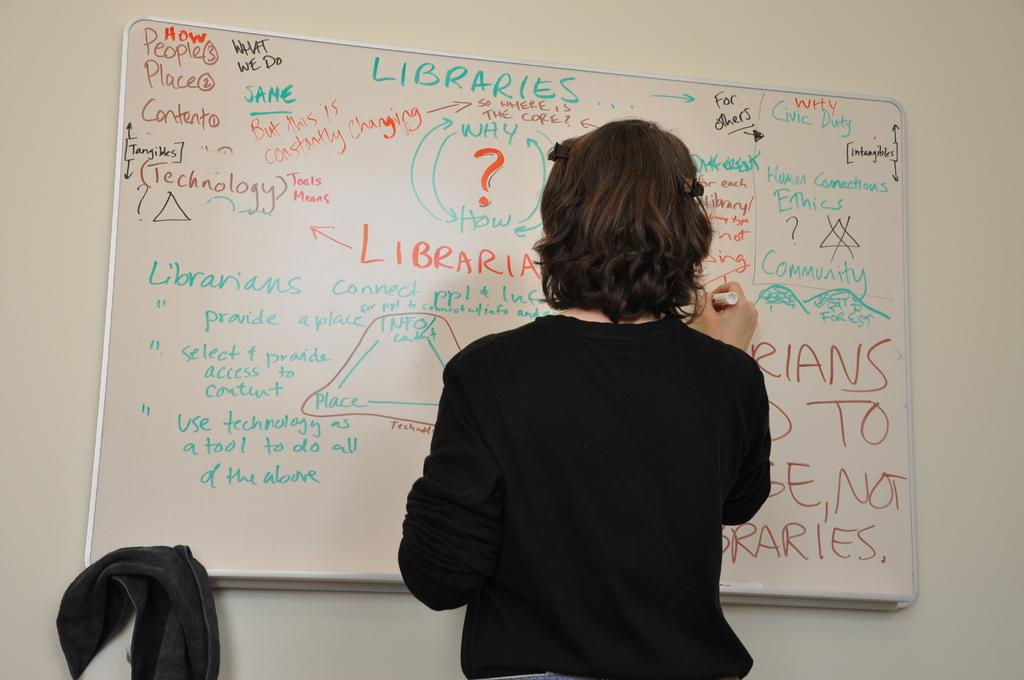<image>
Share a concise interpretation of the image provided. A woman works at a white board that says "libraries" at the top in blue. 